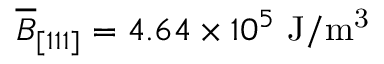<formula> <loc_0><loc_0><loc_500><loc_500>\overline { B } _ { [ 1 1 1 ] } = 4 . 6 4 \times 1 0 ^ { 5 } J / m ^ { 3 }</formula> 